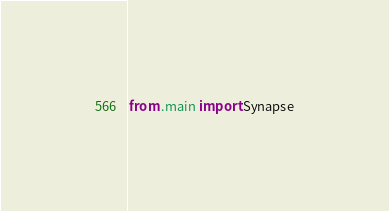Convert code to text. <code><loc_0><loc_0><loc_500><loc_500><_Python_>from .main import Synapse</code> 